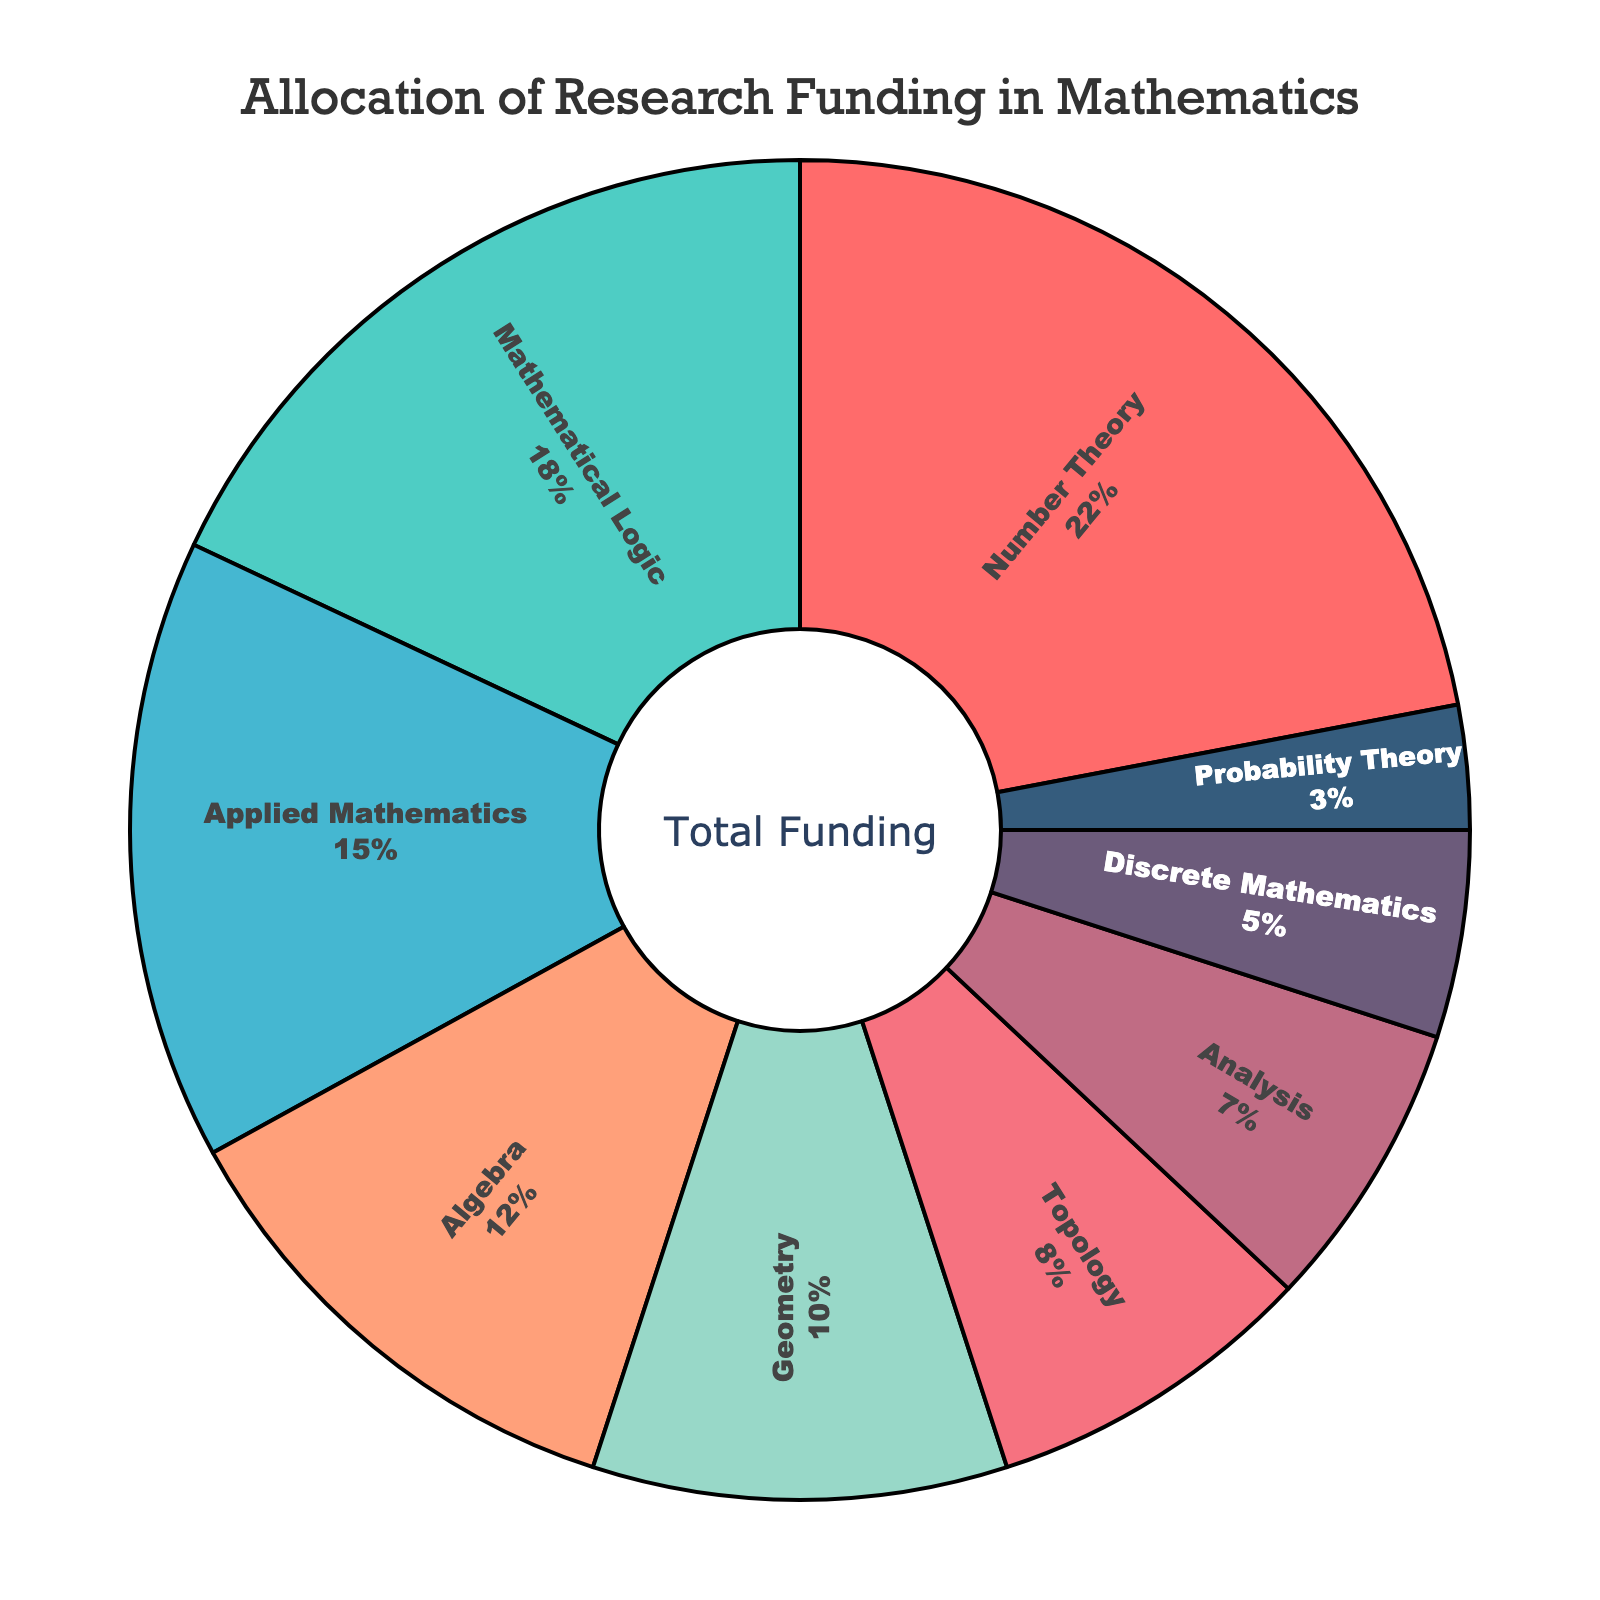Which branch of mathematics has the highest funding percentage? The figure shows that Number Theory occupies the largest segment. Its percentage is 22%.
Answer: Number Theory Which branch has 18% funding? The figure indicates that Mathematical Logic is allocated 18% of the funding.
Answer: Mathematical Logic What is the total funding percentage for Algebra and Geometry? Algebra has 12% and Geometry has 10%. Summing them up: 12% + 10% = 22%.
Answer: 22% How does the funding for Probability Theory compare to Topology? The funding for Probability Theory is 3%, whereas Topology has 8%. Therefore, Topology receives more funding than Probability Theory.
Answer: Topology receives more What percentage of the funding is allocated to branches with an 8% or higher share? The branches with 8% or higher are Number Theory (22%), Mathematical Logic (18%), Applied Mathematics (15%), Algebra (12%), Geometry (10%), and Topology (8%). Summing them: 22% + 18% + 15% + 12% + 10% + 8% = 85%.
Answer: 85% What is the total funding for Discrete Mathematics and Analysis combined? Discrete Mathematics has 5% and Analysis has 7%. Summing these values: 5% + 7% = 12%.
Answer: 12% If the funding for Mathematical Logic was increased by 5%, what would be its new percentage? Currently, Mathematical Logic is 18%. Adding 5%: 18% + 5% = 23%.
Answer: 23% Which branch has the smallest funding percentage and what is it? The smallest segment in the pie chart corresponds to Probability Theory, which has 3%.
Answer: Probability Theory, 3% What is the difference in funding percentage between Applied Mathematics and Geometry? Applied Mathematics has 15% and Geometry has 10%. The difference is 15% - 10% = 5%.
Answer: 5% What is the average funding percentage for the branches with less than 10% allocation? The branches with less than 10% are Topology (8%), Analysis (7%), Discrete Mathematics (5%), and Probability Theory (3%). Summing them: 8% + 7% + 5% + 3% = 23%. The average is 23% / 4 = 5.75%.
Answer: 5.75% 